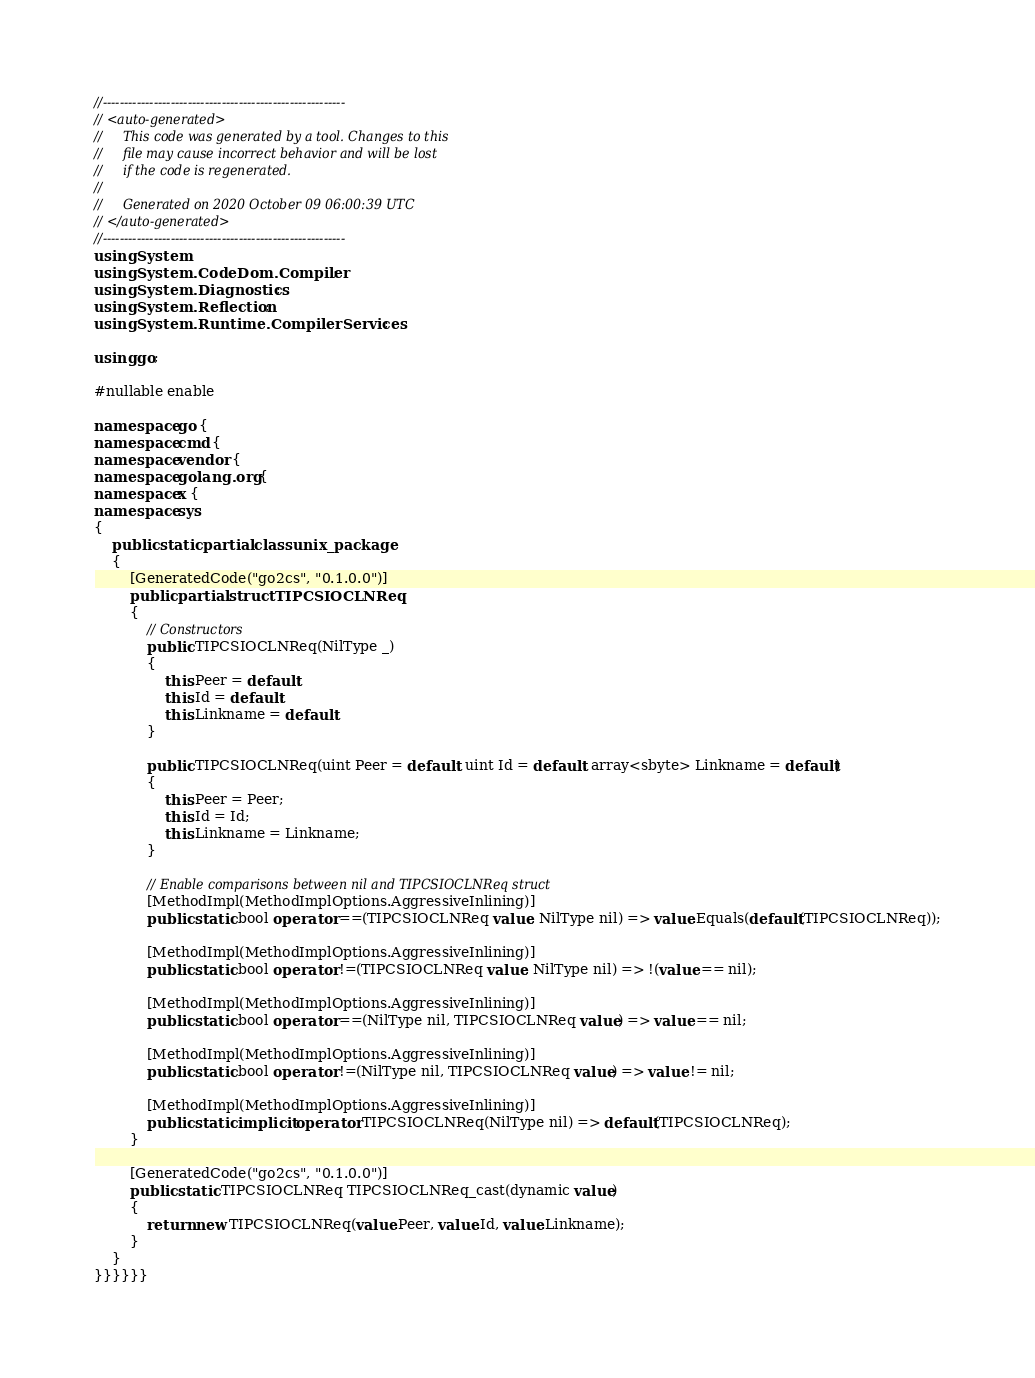<code> <loc_0><loc_0><loc_500><loc_500><_C#_>//---------------------------------------------------------
// <auto-generated>
//     This code was generated by a tool. Changes to this
//     file may cause incorrect behavior and will be lost
//     if the code is regenerated.
//
//     Generated on 2020 October 09 06:00:39 UTC
// </auto-generated>
//---------------------------------------------------------
using System;
using System.CodeDom.Compiler;
using System.Diagnostics;
using System.Reflection;
using System.Runtime.CompilerServices;

using go;

#nullable enable

namespace go {
namespace cmd {
namespace vendor {
namespace golang.org {
namespace x {
namespace sys
{
    public static partial class unix_package
    {
        [GeneratedCode("go2cs", "0.1.0.0")]
        public partial struct TIPCSIOCLNReq
        {
            // Constructors
            public TIPCSIOCLNReq(NilType _)
            {
                this.Peer = default;
                this.Id = default;
                this.Linkname = default;
            }

            public TIPCSIOCLNReq(uint Peer = default, uint Id = default, array<sbyte> Linkname = default)
            {
                this.Peer = Peer;
                this.Id = Id;
                this.Linkname = Linkname;
            }

            // Enable comparisons between nil and TIPCSIOCLNReq struct
            [MethodImpl(MethodImplOptions.AggressiveInlining)]
            public static bool operator ==(TIPCSIOCLNReq value, NilType nil) => value.Equals(default(TIPCSIOCLNReq));

            [MethodImpl(MethodImplOptions.AggressiveInlining)]
            public static bool operator !=(TIPCSIOCLNReq value, NilType nil) => !(value == nil);

            [MethodImpl(MethodImplOptions.AggressiveInlining)]
            public static bool operator ==(NilType nil, TIPCSIOCLNReq value) => value == nil;

            [MethodImpl(MethodImplOptions.AggressiveInlining)]
            public static bool operator !=(NilType nil, TIPCSIOCLNReq value) => value != nil;

            [MethodImpl(MethodImplOptions.AggressiveInlining)]
            public static implicit operator TIPCSIOCLNReq(NilType nil) => default(TIPCSIOCLNReq);
        }

        [GeneratedCode("go2cs", "0.1.0.0")]
        public static TIPCSIOCLNReq TIPCSIOCLNReq_cast(dynamic value)
        {
            return new TIPCSIOCLNReq(value.Peer, value.Id, value.Linkname);
        }
    }
}}}}}}</code> 